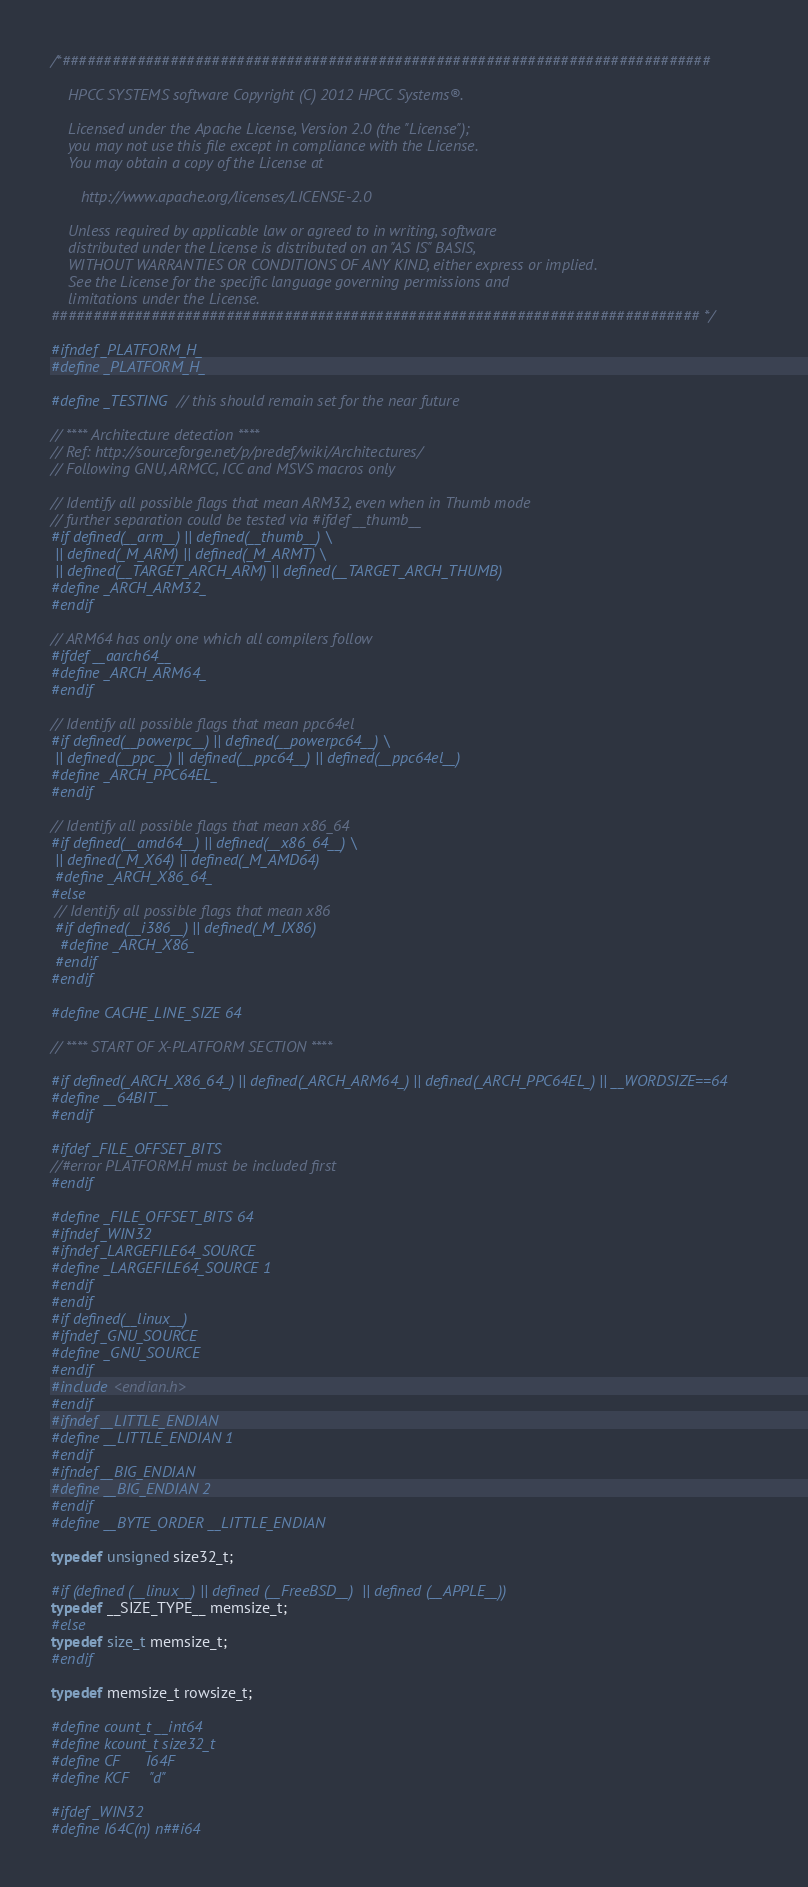Convert code to text. <code><loc_0><loc_0><loc_500><loc_500><_C_>/*##############################################################################

    HPCC SYSTEMS software Copyright (C) 2012 HPCC Systems®.

    Licensed under the Apache License, Version 2.0 (the "License");
    you may not use this file except in compliance with the License.
    You may obtain a copy of the License at

       http://www.apache.org/licenses/LICENSE-2.0

    Unless required by applicable law or agreed to in writing, software
    distributed under the License is distributed on an "AS IS" BASIS,
    WITHOUT WARRANTIES OR CONDITIONS OF ANY KIND, either express or implied.
    See the License for the specific language governing permissions and
    limitations under the License.
############################################################################## */

#ifndef _PLATFORM_H_
#define _PLATFORM_H_

#define _TESTING // this should remain set for the near future

// **** Architecture detection ****
// Ref: http://sourceforge.net/p/predef/wiki/Architectures/
// Following GNU, ARMCC, ICC and MSVS macros only

// Identify all possible flags that mean ARM32, even when in Thumb mode
// further separation could be tested via #ifdef __thumb__
#if defined(__arm__) || defined(__thumb__) \
 || defined(_M_ARM) || defined(_M_ARMT) \
 || defined(__TARGET_ARCH_ARM) || defined(__TARGET_ARCH_THUMB)
#define _ARCH_ARM32_
#endif

// ARM64 has only one which all compilers follow
#ifdef __aarch64__
#define _ARCH_ARM64_
#endif

// Identify all possible flags that mean ppc64el
#if defined(__powerpc__) || defined(__powerpc64__) \
 || defined(__ppc__) || defined(__ppc64__) || defined(__ppc64el__)
#define _ARCH_PPC64EL_
#endif

// Identify all possible flags that mean x86_64
#if defined(__amd64__) || defined(__x86_64__) \
 || defined(_M_X64) || defined(_M_AMD64)
 #define _ARCH_X86_64_
#else
 // Identify all possible flags that mean x86
 #if defined(__i386__) || defined(_M_IX86)
  #define _ARCH_X86_
 #endif
#endif

#define CACHE_LINE_SIZE 64

// **** START OF X-PLATFORM SECTION ****

#if defined(_ARCH_X86_64_) || defined(_ARCH_ARM64_) || defined(_ARCH_PPC64EL_) || __WORDSIZE==64
#define __64BIT__
#endif

#ifdef _FILE_OFFSET_BITS
//#error PLATFORM.H must be included first
#endif

#define _FILE_OFFSET_BITS 64
#ifndef _WIN32
#ifndef _LARGEFILE64_SOURCE
#define _LARGEFILE64_SOURCE 1
#endif
#endif
#if defined(__linux__)
#ifndef _GNU_SOURCE
#define _GNU_SOURCE
#endif
#include <endian.h>
#endif
#ifndef __LITTLE_ENDIAN
#define __LITTLE_ENDIAN 1
#endif
#ifndef __BIG_ENDIAN
#define __BIG_ENDIAN 2
#endif
#define __BYTE_ORDER __LITTLE_ENDIAN

typedef unsigned size32_t;

#if (defined (__linux__) || defined (__FreeBSD__)  || defined (__APPLE__))
typedef __SIZE_TYPE__ memsize_t;
#else
typedef size_t memsize_t;
#endif

typedef memsize_t rowsize_t;

#define count_t __int64
#define kcount_t size32_t
#define CF      I64F
#define KCF     "d"

#ifdef _WIN32
#define I64C(n) n##i64</code> 